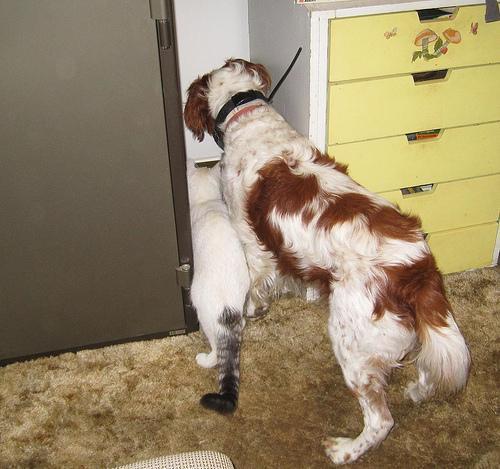How many dogs are in the picture?
Give a very brief answer. 1. 